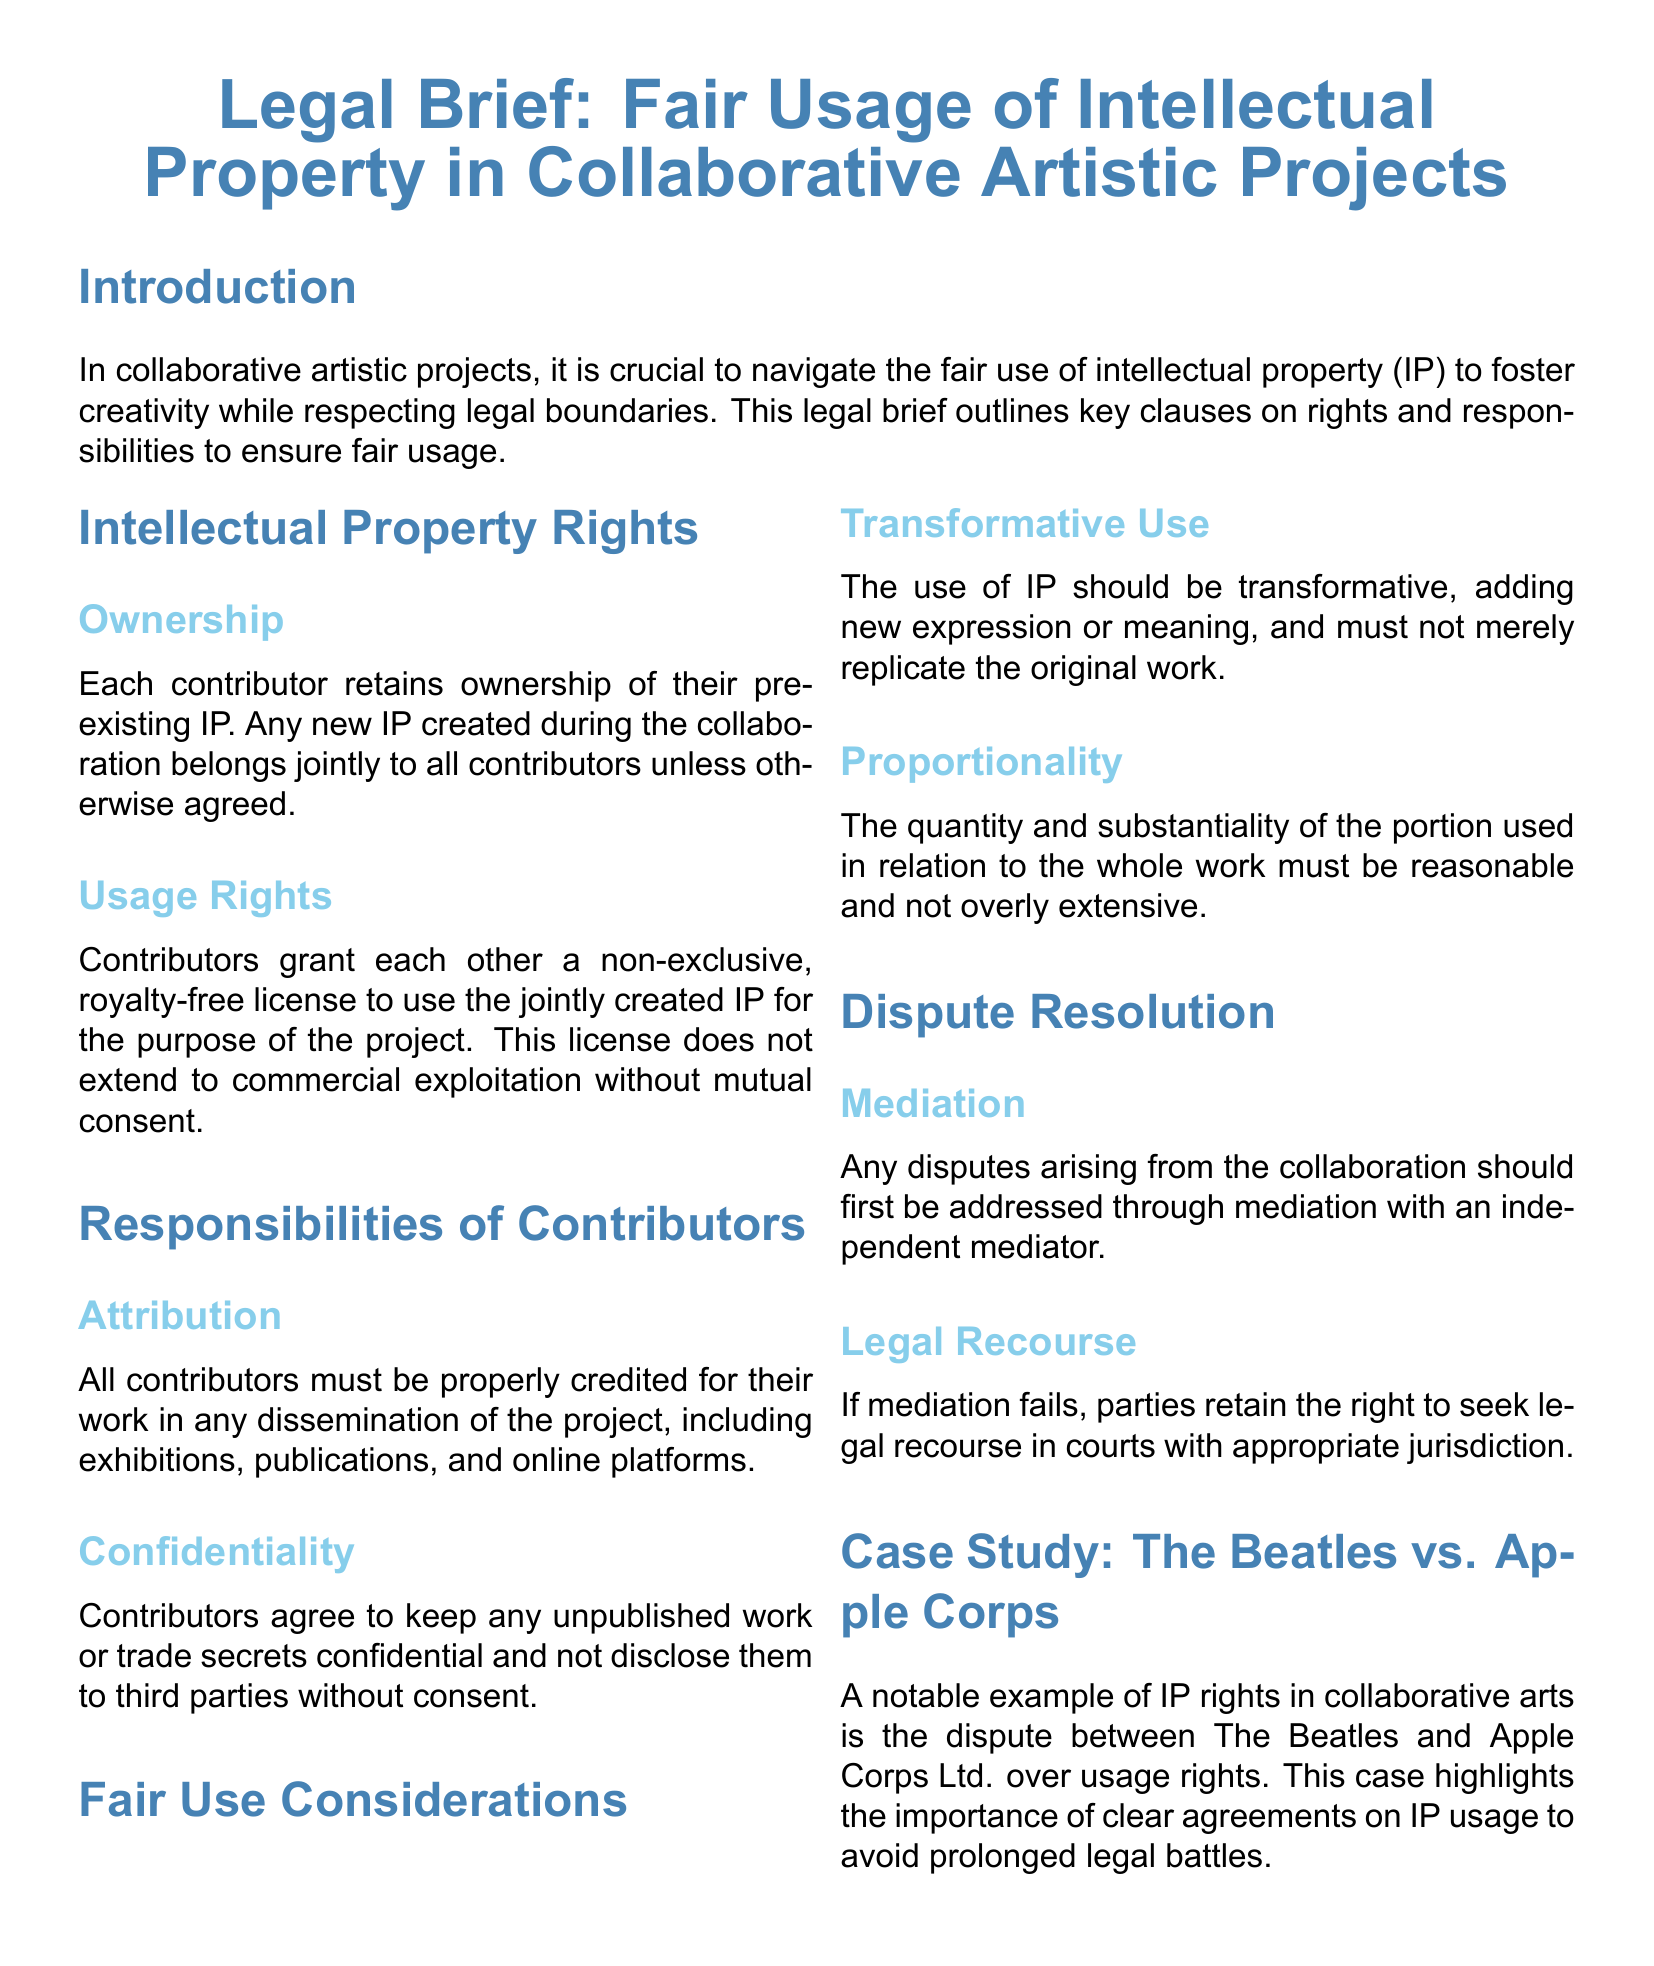What is the title of the document? The title is clearly stated at the top of the document.
Answer: Legal Brief: Fair Usage of Intellectual Property in Collaborative Artistic Projects What must contributors do in terms of attribution? The responsibilities section specifies what is required regarding credit.
Answer: Properly credited What is the initial method for resolving disputes? The dispute resolution section outlines the first step in resolving issues.
Answer: Mediation What type of license do contributors grant each other? This information is found in the usage rights subsection.
Answer: Non-exclusive, royalty-free license What is required for transformative use of IP? This condition is mentioned under fair use considerations.
Answer: Adding new expression or meaning Who retains ownership of pre-existing IP? The ownership clause clearly states who keeps their rights.
Answer: Each contributor What happens if mediation fails? The legal recourse section explains the next steps if mediation does not work.
Answer: Seek legal recourse What is the key topic of the case study? The case study emphasizes a significant example discussed in the document.
Answer: IP rights in collaborative arts What must contributors keep confidential? The confidentiality subsection outlines what needs to be protected.
Answer: Unpublished work or trade secrets 